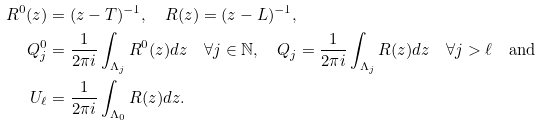<formula> <loc_0><loc_0><loc_500><loc_500>R ^ { 0 } ( z ) & = ( z - T ) ^ { - 1 } , \quad R ( z ) = ( z - L ) ^ { - 1 } , \\ Q _ { j } ^ { 0 } & = \frac { 1 } { 2 \pi i } \int _ { \Lambda _ { j } } R ^ { 0 } ( z ) d z \quad \forall j \in \mathbb { N } , \quad Q _ { j } = \frac { 1 } { 2 \pi i } \int _ { \Lambda _ { j } } R ( z ) d z \quad \forall j > \ell \quad \text {and} \\ U _ { \ell } & = \frac { 1 } { 2 \pi i } \int _ { \Lambda _ { 0 } } R ( z ) d z .</formula> 